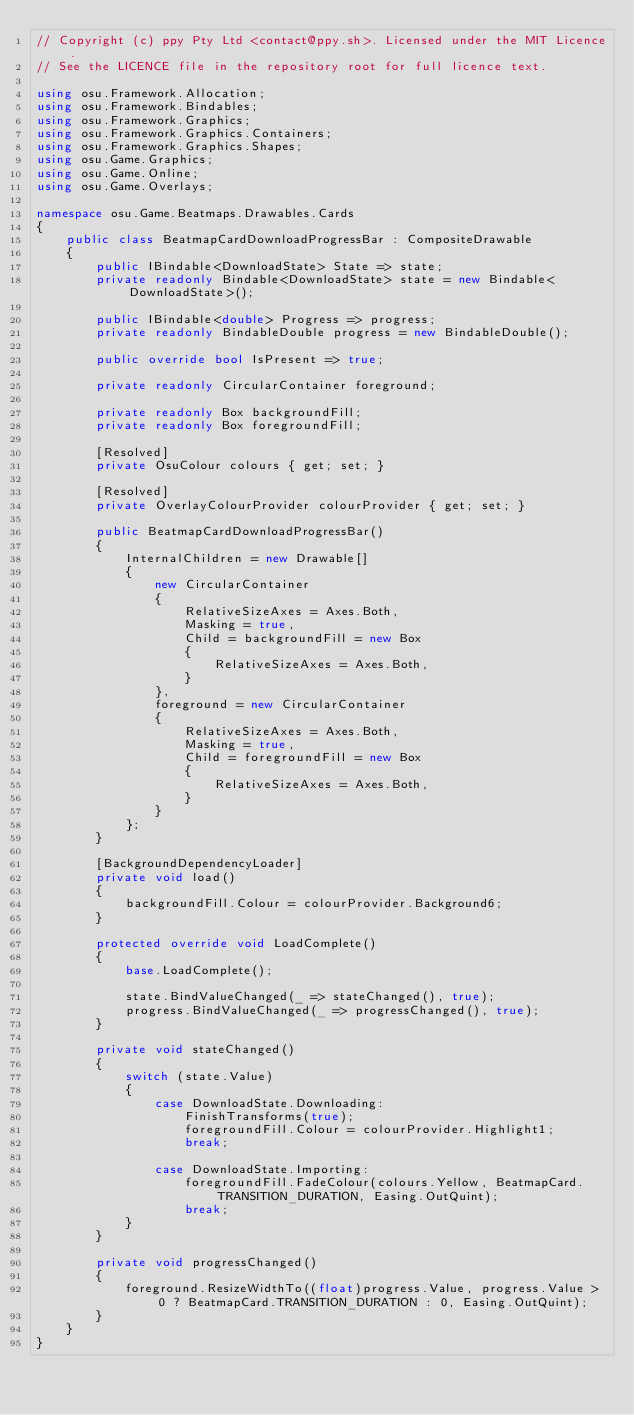Convert code to text. <code><loc_0><loc_0><loc_500><loc_500><_C#_>// Copyright (c) ppy Pty Ltd <contact@ppy.sh>. Licensed under the MIT Licence.
// See the LICENCE file in the repository root for full licence text.

using osu.Framework.Allocation;
using osu.Framework.Bindables;
using osu.Framework.Graphics;
using osu.Framework.Graphics.Containers;
using osu.Framework.Graphics.Shapes;
using osu.Game.Graphics;
using osu.Game.Online;
using osu.Game.Overlays;

namespace osu.Game.Beatmaps.Drawables.Cards
{
    public class BeatmapCardDownloadProgressBar : CompositeDrawable
    {
        public IBindable<DownloadState> State => state;
        private readonly Bindable<DownloadState> state = new Bindable<DownloadState>();

        public IBindable<double> Progress => progress;
        private readonly BindableDouble progress = new BindableDouble();

        public override bool IsPresent => true;

        private readonly CircularContainer foreground;

        private readonly Box backgroundFill;
        private readonly Box foregroundFill;

        [Resolved]
        private OsuColour colours { get; set; }

        [Resolved]
        private OverlayColourProvider colourProvider { get; set; }

        public BeatmapCardDownloadProgressBar()
        {
            InternalChildren = new Drawable[]
            {
                new CircularContainer
                {
                    RelativeSizeAxes = Axes.Both,
                    Masking = true,
                    Child = backgroundFill = new Box
                    {
                        RelativeSizeAxes = Axes.Both,
                    }
                },
                foreground = new CircularContainer
                {
                    RelativeSizeAxes = Axes.Both,
                    Masking = true,
                    Child = foregroundFill = new Box
                    {
                        RelativeSizeAxes = Axes.Both,
                    }
                }
            };
        }

        [BackgroundDependencyLoader]
        private void load()
        {
            backgroundFill.Colour = colourProvider.Background6;
        }

        protected override void LoadComplete()
        {
            base.LoadComplete();

            state.BindValueChanged(_ => stateChanged(), true);
            progress.BindValueChanged(_ => progressChanged(), true);
        }

        private void stateChanged()
        {
            switch (state.Value)
            {
                case DownloadState.Downloading:
                    FinishTransforms(true);
                    foregroundFill.Colour = colourProvider.Highlight1;
                    break;

                case DownloadState.Importing:
                    foregroundFill.FadeColour(colours.Yellow, BeatmapCard.TRANSITION_DURATION, Easing.OutQuint);
                    break;
            }
        }

        private void progressChanged()
        {
            foreground.ResizeWidthTo((float)progress.Value, progress.Value > 0 ? BeatmapCard.TRANSITION_DURATION : 0, Easing.OutQuint);
        }
    }
}
</code> 